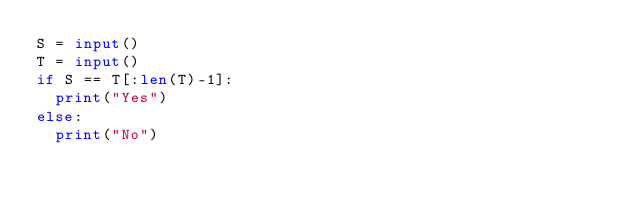<code> <loc_0><loc_0><loc_500><loc_500><_Python_>S = input()
T = input()
if S == T[:len(T)-1]:
  print("Yes")
else:
  print("No")</code> 